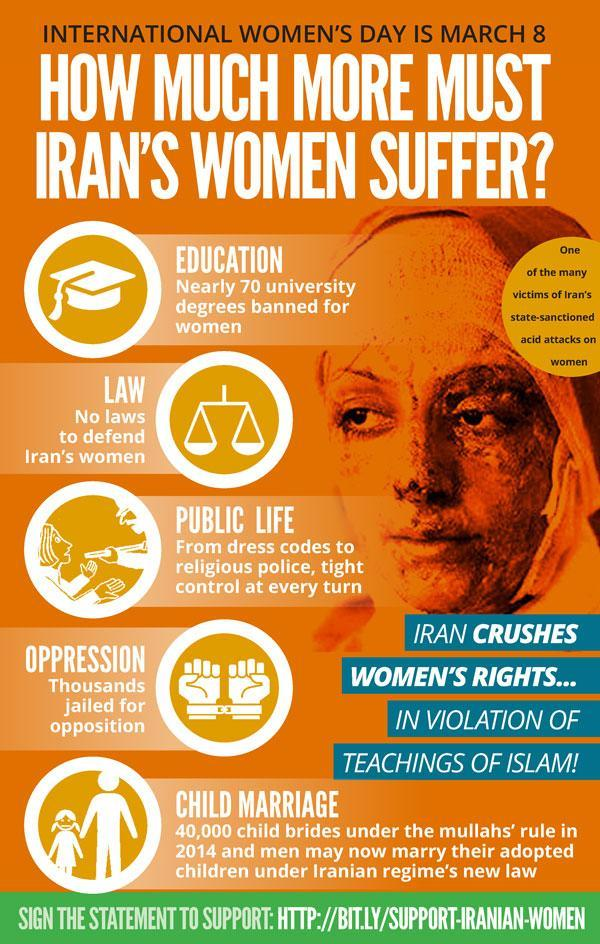The woman shown in the graphic is a victim of what form of violence?
Answer the question with a short phrase. state-sanctioned acid attacks on women Why have thousands of women been jailed for? opposition 